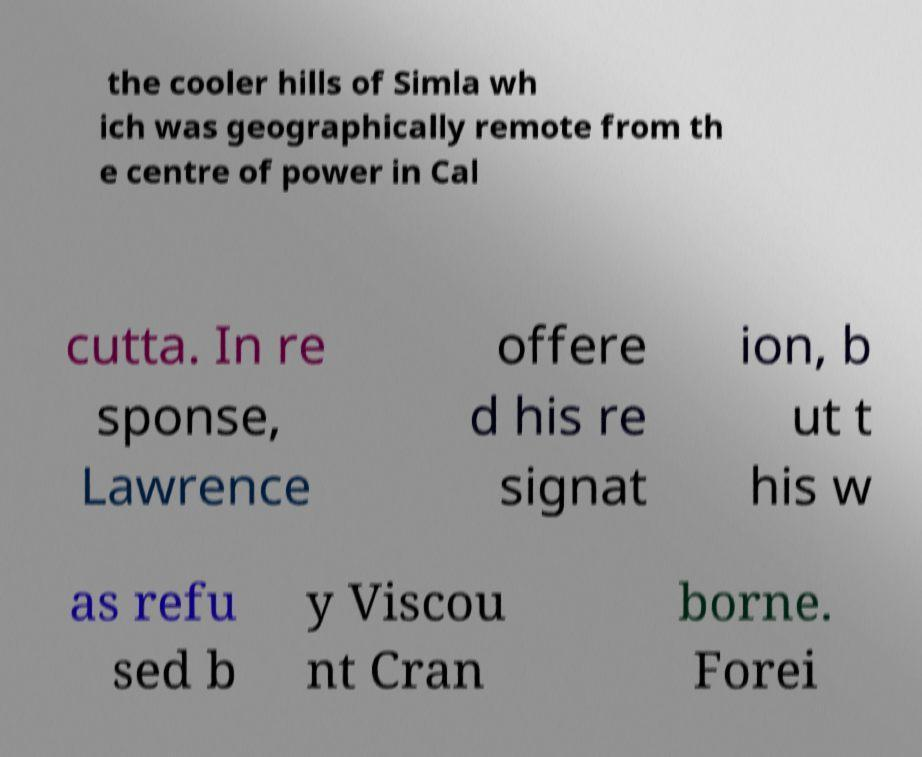Could you extract and type out the text from this image? the cooler hills of Simla wh ich was geographically remote from th e centre of power in Cal cutta. In re sponse, Lawrence offere d his re signat ion, b ut t his w as refu sed b y Viscou nt Cran borne. Forei 